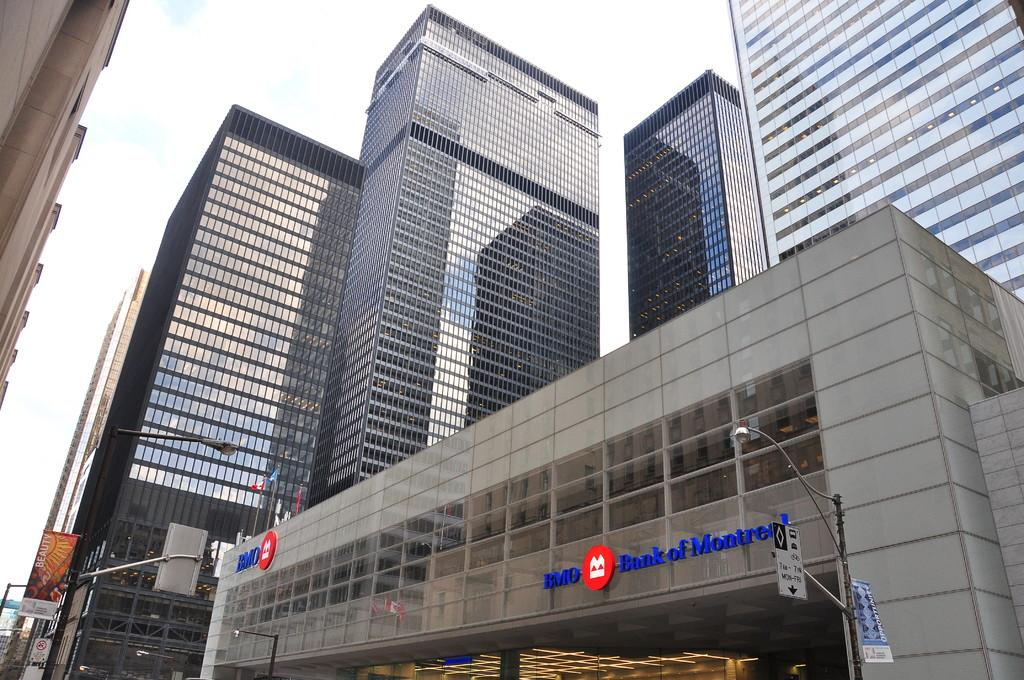<image>
Render a clear and concise summary of the photo. The outside of a BMO Bank of Montreal building. 